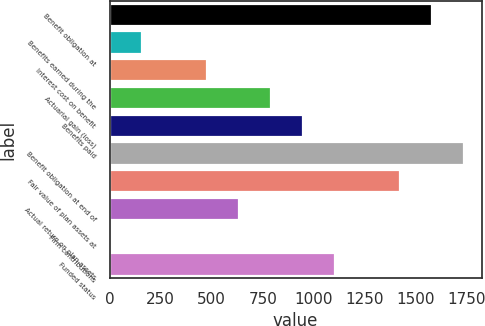Convert chart to OTSL. <chart><loc_0><loc_0><loc_500><loc_500><bar_chart><fcel>Benefit obligation at<fcel>Benefits earned during the<fcel>Interest cost on benefit<fcel>Actuarial gain (loss)<fcel>Benefits paid<fcel>Benefit obligation at end of<fcel>Fair value of plan assets at<fcel>Actual return on plan assets<fcel>Firm contributions<fcel>Funded status<nl><fcel>1577<fcel>159.5<fcel>474.5<fcel>789.5<fcel>947<fcel>1734.5<fcel>1419.5<fcel>632<fcel>2<fcel>1104.5<nl></chart> 